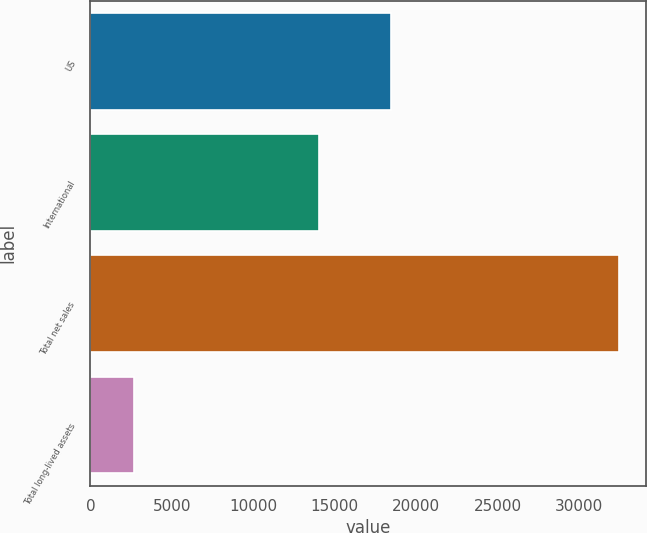Convert chart. <chart><loc_0><loc_0><loc_500><loc_500><bar_chart><fcel>US<fcel>International<fcel>Total net sales<fcel>Total long-lived assets<nl><fcel>18469<fcel>14010<fcel>32479<fcel>2679<nl></chart> 